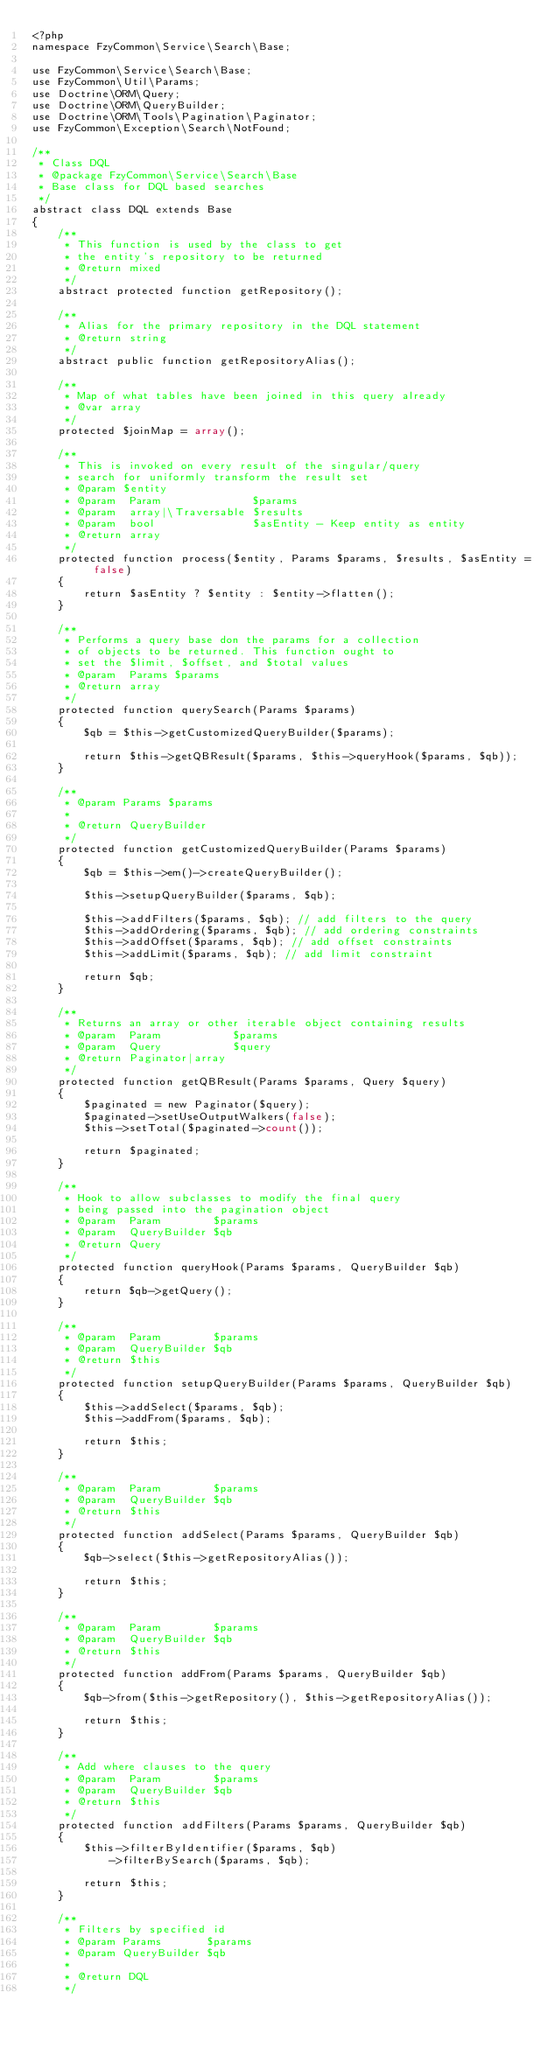<code> <loc_0><loc_0><loc_500><loc_500><_PHP_><?php
namespace FzyCommon\Service\Search\Base;

use FzyCommon\Service\Search\Base;
use FzyCommon\Util\Params;
use Doctrine\ORM\Query;
use Doctrine\ORM\QueryBuilder;
use Doctrine\ORM\Tools\Pagination\Paginator;
use FzyCommon\Exception\Search\NotFound;

/**
 * Class DQL
 * @package FzyCommon\Service\Search\Base
 * Base class for DQL based searches
 */
abstract class DQL extends Base
{
    /**
     * This function is used by the class to get
     * the entity's repository to be returned
     * @return mixed
     */
    abstract protected function getRepository();

    /**
     * Alias for the primary repository in the DQL statement
     * @return string
     */
    abstract public function getRepositoryAlias();

    /**
     * Map of what tables have been joined in this query already
     * @var array
     */
    protected $joinMap = array();

    /**
     * This is invoked on every result of the singular/query
     * search for uniformly transform the result set
     * @param $entity
     * @param  Param              $params
     * @param  array|\Traversable $results
     * @param  bool               $asEntity - Keep entity as entity
     * @return array
     */
    protected function process($entity, Params $params, $results, $asEntity = false)
    {
        return $asEntity ? $entity : $entity->flatten();
    }

    /**
     * Performs a query base don the params for a collection
     * of objects to be returned. This function ought to
     * set the $limit, $offset, and $total values
     * @param  Params $params
     * @return array
     */
    protected function querySearch(Params $params)
    {
        $qb = $this->getCustomizedQueryBuilder($params);

        return $this->getQBResult($params, $this->queryHook($params, $qb));
    }

    /**
     * @param Params $params
     *
     * @return QueryBuilder
     */
    protected function getCustomizedQueryBuilder(Params $params)
    {
        $qb = $this->em()->createQueryBuilder();

        $this->setupQueryBuilder($params, $qb);

        $this->addFilters($params, $qb); // add filters to the query
        $this->addOrdering($params, $qb); // add ordering constraints
        $this->addOffset($params, $qb); // add offset constraints
        $this->addLimit($params, $qb); // add limit constraint

        return $qb;
    }

    /**
     * Returns an array or other iterable object containing results
     * @param  Param           $params
     * @param  Query           $query
     * @return Paginator|array
     */
    protected function getQBResult(Params $params, Query $query)
    {
        $paginated = new Paginator($query);
        $paginated->setUseOutputWalkers(false);
        $this->setTotal($paginated->count());

        return $paginated;
    }

    /**
     * Hook to allow subclasses to modify the final query
     * being passed into the pagination object
     * @param  Param        $params
     * @param  QueryBuilder $qb
     * @return Query
     */
    protected function queryHook(Params $params, QueryBuilder $qb)
    {
        return $qb->getQuery();
    }

    /**
     * @param  Param        $params
     * @param  QueryBuilder $qb
     * @return $this
     */
    protected function setupQueryBuilder(Params $params, QueryBuilder $qb)
    {
        $this->addSelect($params, $qb);
        $this->addFrom($params, $qb);

        return $this;
    }

    /**
     * @param  Param        $params
     * @param  QueryBuilder $qb
     * @return $this
     */
    protected function addSelect(Params $params, QueryBuilder $qb)
    {
        $qb->select($this->getRepositoryAlias());

        return $this;
    }

    /**
     * @param  Param        $params
     * @param  QueryBuilder $qb
     * @return $this
     */
    protected function addFrom(Params $params, QueryBuilder $qb)
    {
        $qb->from($this->getRepository(), $this->getRepositoryAlias());

        return $this;
    }

    /**
     * Add where clauses to the query
     * @param  Param        $params
     * @param  QueryBuilder $qb
     * @return $this
     */
    protected function addFilters(Params $params, QueryBuilder $qb)
    {
        $this->filterByIdentifier($params, $qb)
            ->filterBySearch($params, $qb);

        return $this;
    }

    /**
     * Filters by specified id
     * @param Params       $params
     * @param QueryBuilder $qb
     *
     * @return DQL
     */</code> 